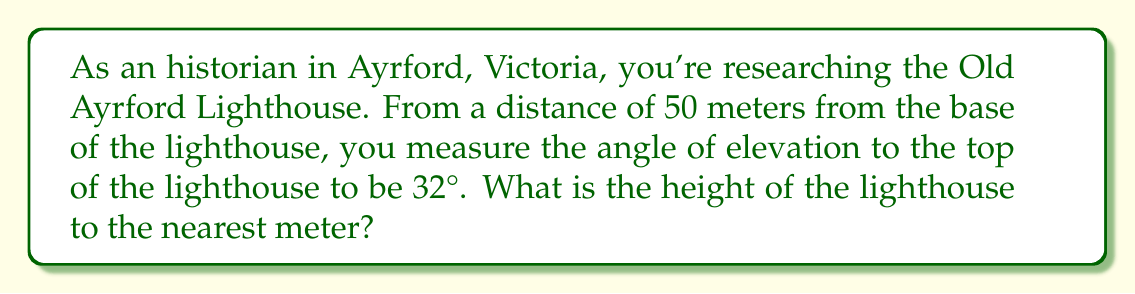Solve this math problem. To solve this problem, we'll use trigonometry, specifically the tangent function. Let's approach this step-by-step:

1) First, let's visualize the problem:

[asy]
import geometry;

size(200);
pair A = (0,0), B = (5,0), C = (5,3.12);
draw(A--B--C--A);
label("50m", (A--B), S);
label("h", (B--C), E);
label("32°", A, SW);
dot("A", A, SW);
dot("B", B, SE);
dot("C", C, NE);
[/asy]

2) In this right-angled triangle:
   - The adjacent side is the distance from the observer to the base (50m)
   - The opposite side is the height of the lighthouse (h)
   - The angle of elevation is 32°

3) We can use the tangent function, which is defined as:

   $$\tan(\theta) = \frac{\text{opposite}}{\text{adjacent}}$$

4) Substituting our values:

   $$\tan(32°) = \frac{h}{50}$$

5) To solve for h, we multiply both sides by 50:

   $$h = 50 \cdot \tan(32°)$$

6) Now we can calculate:
   $$h = 50 \cdot \tan(32°) \approx 50 \cdot 0.6249 \approx 31.24$$

7) Rounding to the nearest meter:

   $$h \approx 31 \text{ meters}$$
Answer: 31 meters 